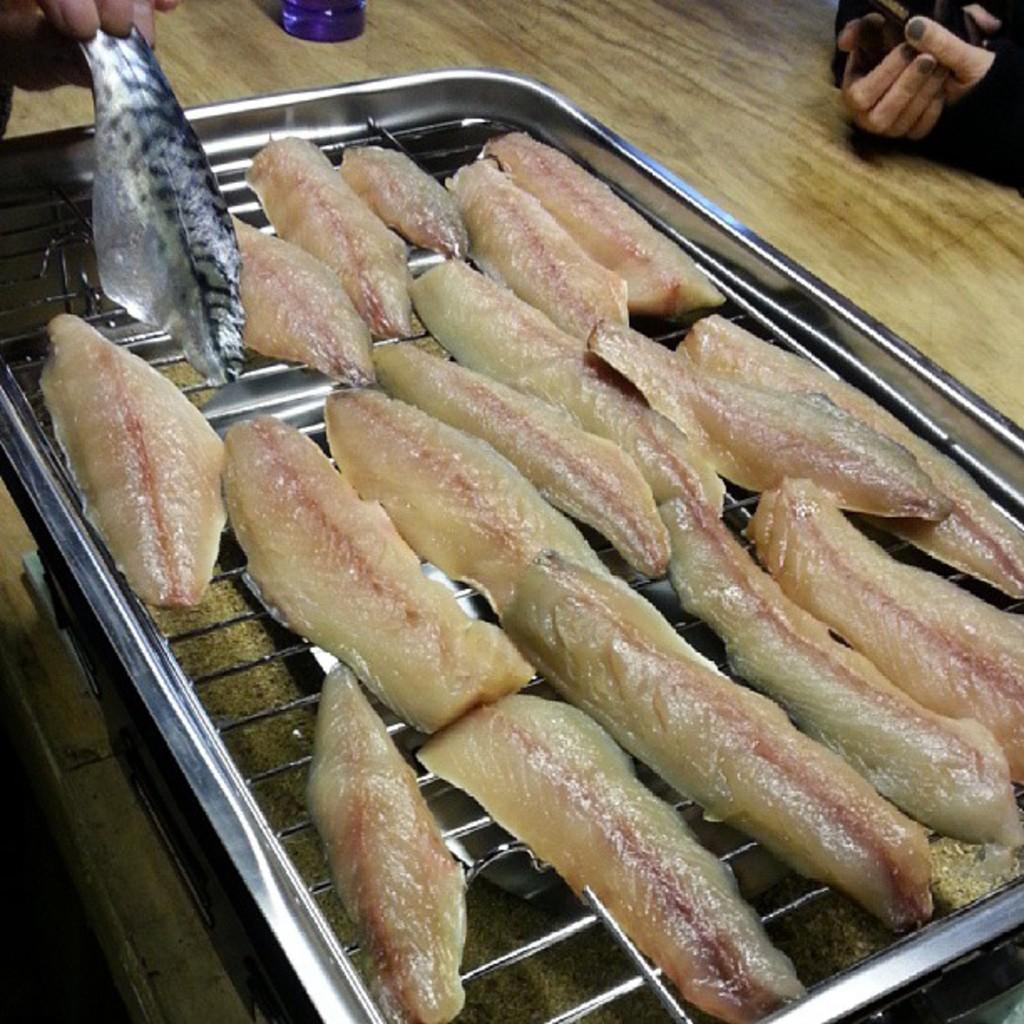In one or two sentences, can you explain what this image depicts? In this image there are hands of a person on the right corner. There are hands of a person on the left corner. There is an object in the background. And we can see a table, There is meat on the metal object in the foreground. 